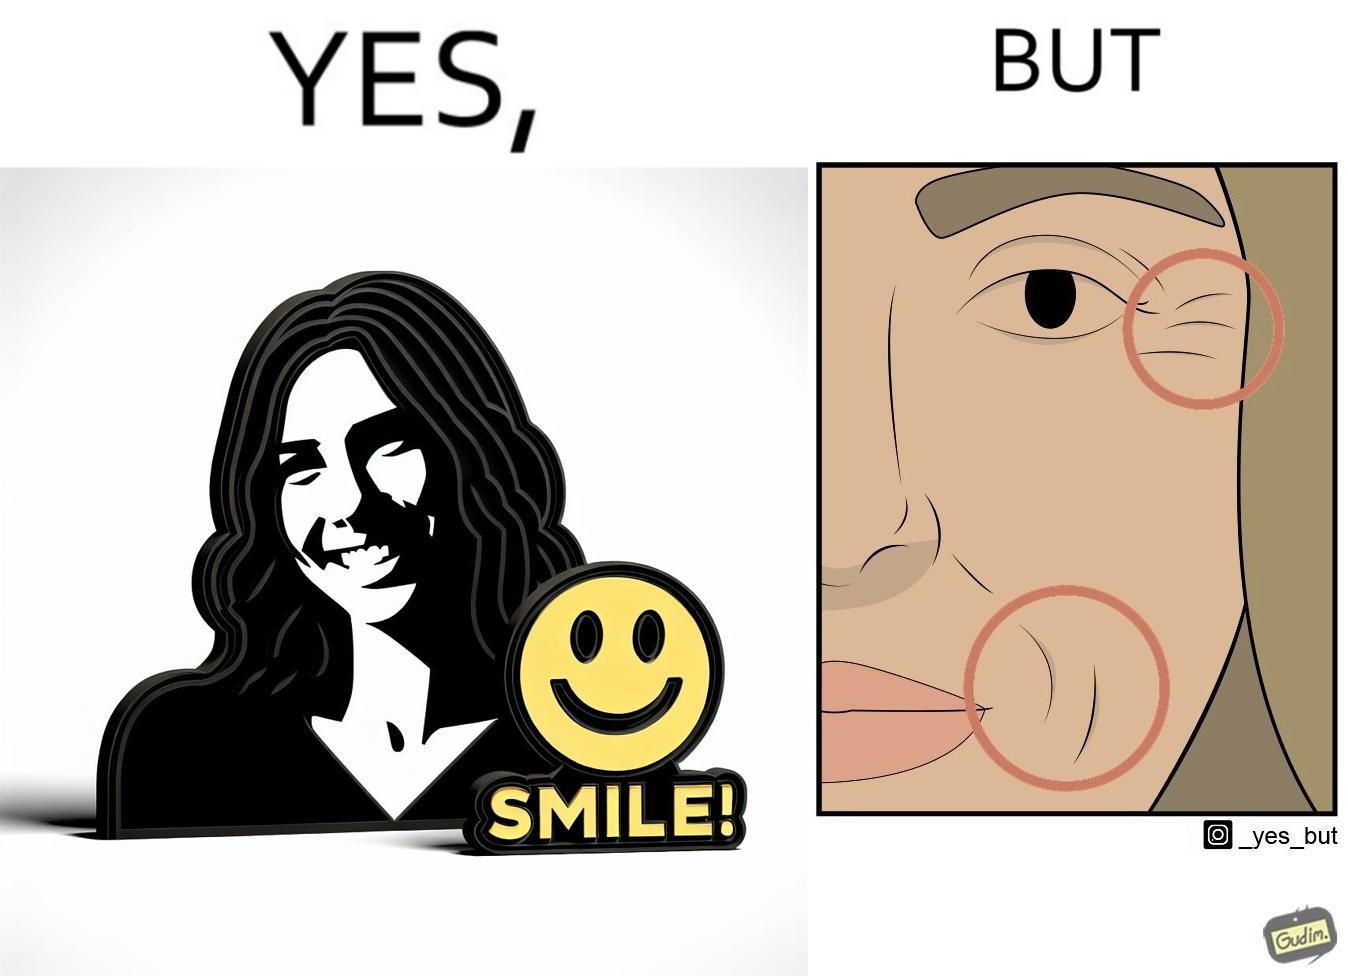What does this image depict? The image is ironical because while it suggests people to smile it also shows the wrinkles that can be caused around lips and eyes because of smiling 